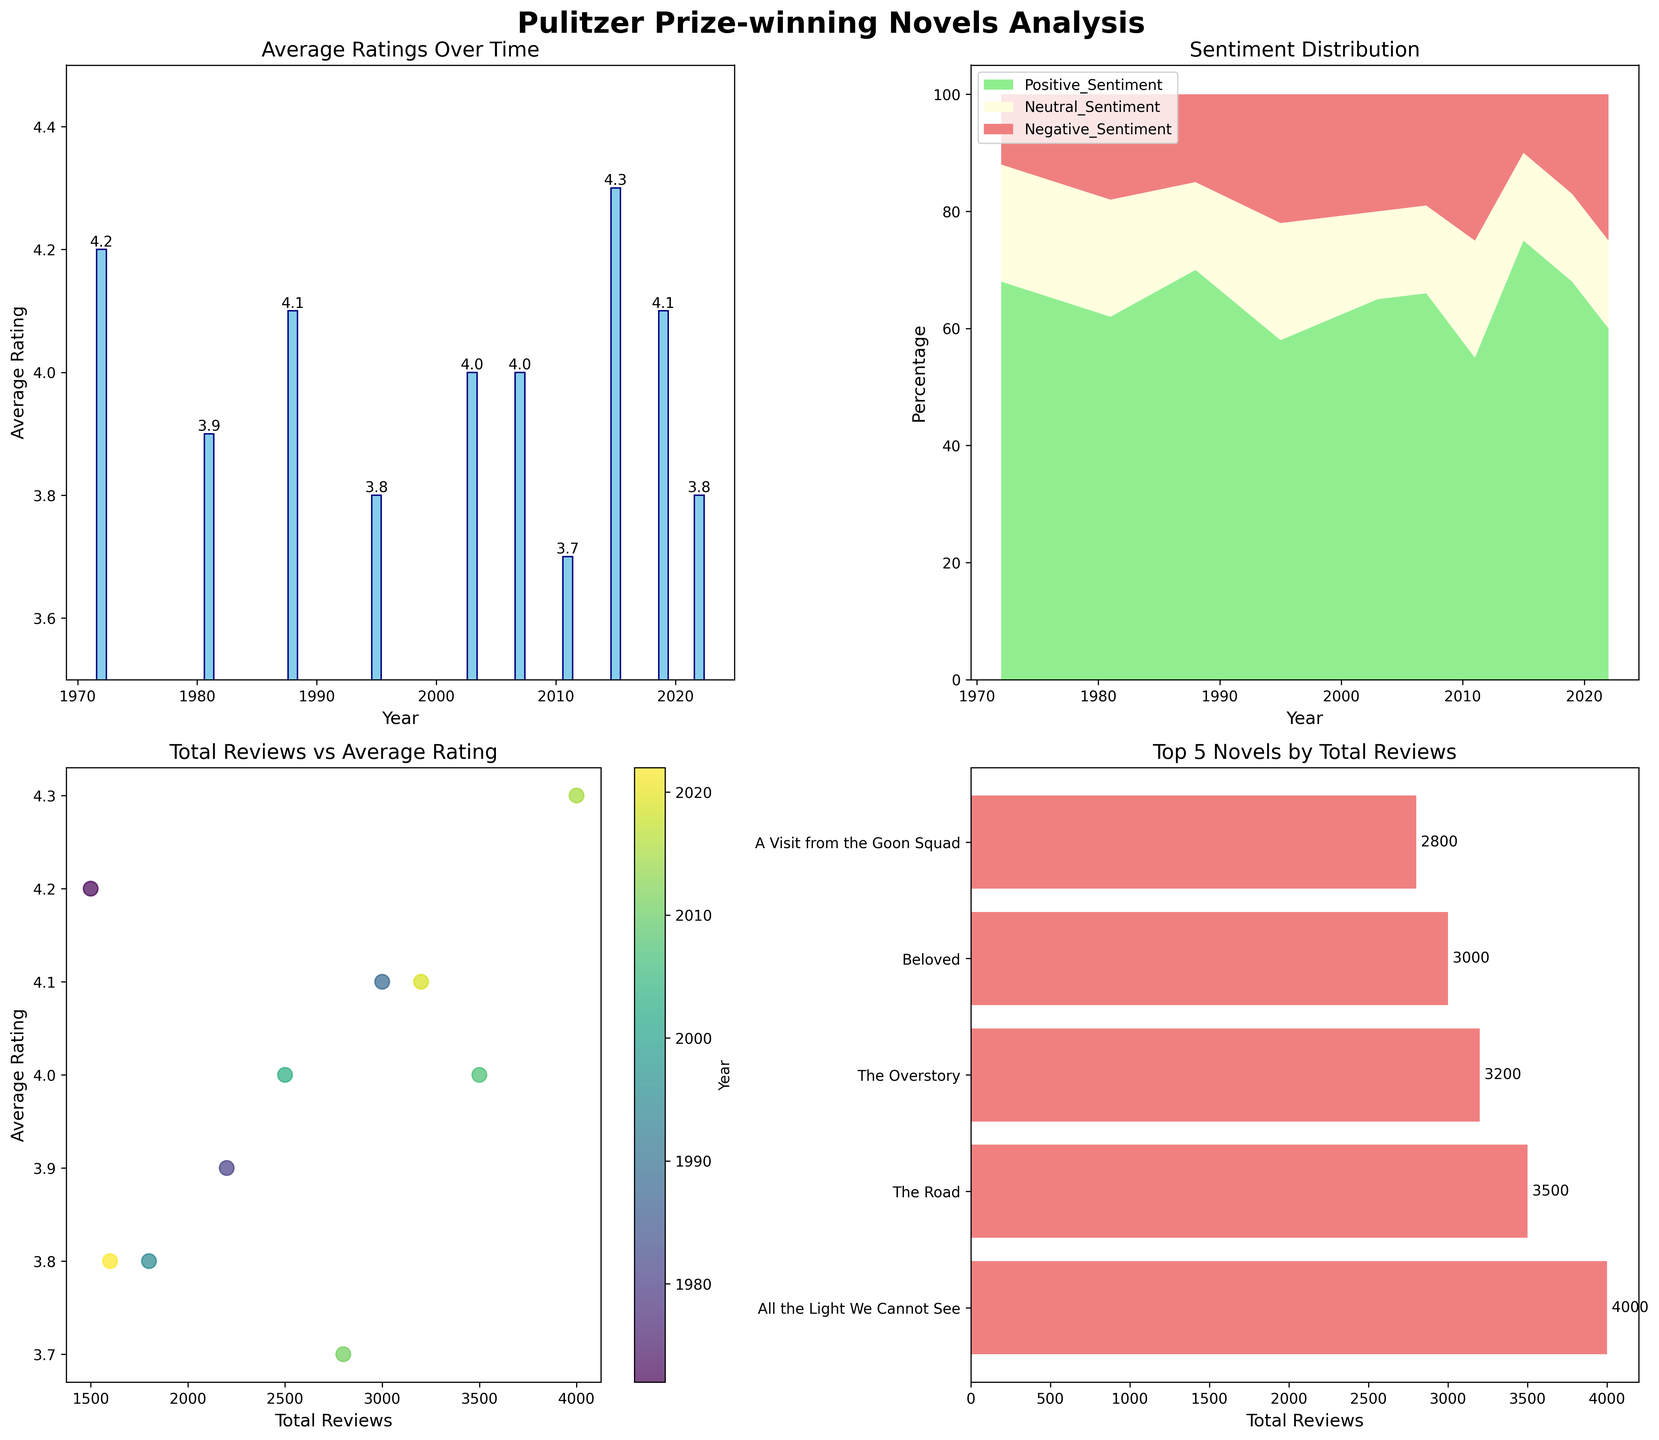How does the average rating trend over the years shown in the bar chart? The bar chart shows average ratings over different years. By observing the heights of the bars from 1972 to 2022, ratings seem relatively stable, with small fluctuations between 3.7 and 4.3.
Answer: Stable with small fluctuations Which year has the highest average rating, and what is it? The bar chart in subplot 1 shows that 2015 has the highest average rating with a value of 4.3, visible as the tallest bar reaching the highest point on the axis.
Answer: 2015 with 4.3 What is the total positive sentiment for the year 2019 as shown in the stacked area chart? The stacked area chart shows three different sentiment areas. For 2019, the area corresponding to the light green color for positive sentiment is marked around 68 percent.
Answer: 68% Compare the total reviews of novels in 1981 and 2003, which one has more? From the scatter plot in subplot 3, it's clear that the marker for 1981 is located below the marker for 2003 on the x-axis, aligning with fewer reviews. Thus, the novel from 2003 has more reviews.
Answer: 2003 Which novel has received the most reviews according to the horizontal bar chart, and how many reviews is it? In the subplot 4 horizontal bar chart, "All the Light We Cannot See" is shown at the top position, with the bar extending to the furthest point, indicating 4000 reviews.
Answer: "All the Light We Cannot See" with 4000 reviews What percentage difference is there between positive and negative sentiment for the novel "The Netanyahus" in 2022? From the data provided, "The Netanyahus" has 60% positive sentiment and 25% negative sentiment. The percentage difference is calculated as 60% - 25% = 35%.
Answer: 35% Which year shows a balanced sentiment distribution, and what does the stacked area chart indicate? The stacked area chart shows that around the year 1972, the sentiments are relatively balanced with the positive sentiment around 68%, neutral sentiment around 20%, and negative sentiment around 12%, making it the most balanced among the years.
Answer: 1972 Considering only the provided top 5 novels by review count, what is the average total number of reviews? Adding up the reviews for top 5 novels: 4000 + 3500 + 3200 + 3000 + 2800 = 16500. Dividing by 5 gives 16500 / 5 = 3300.
Answer: 3300 Identify the novel with the lowest average rating and its year. Referring to the lowest bar in subplot 1, "A Visit from the Goon Squad" in 2011 has the lowest rating of 3.7.
Answer: "A Visit from the Goon Squad" in 2011 